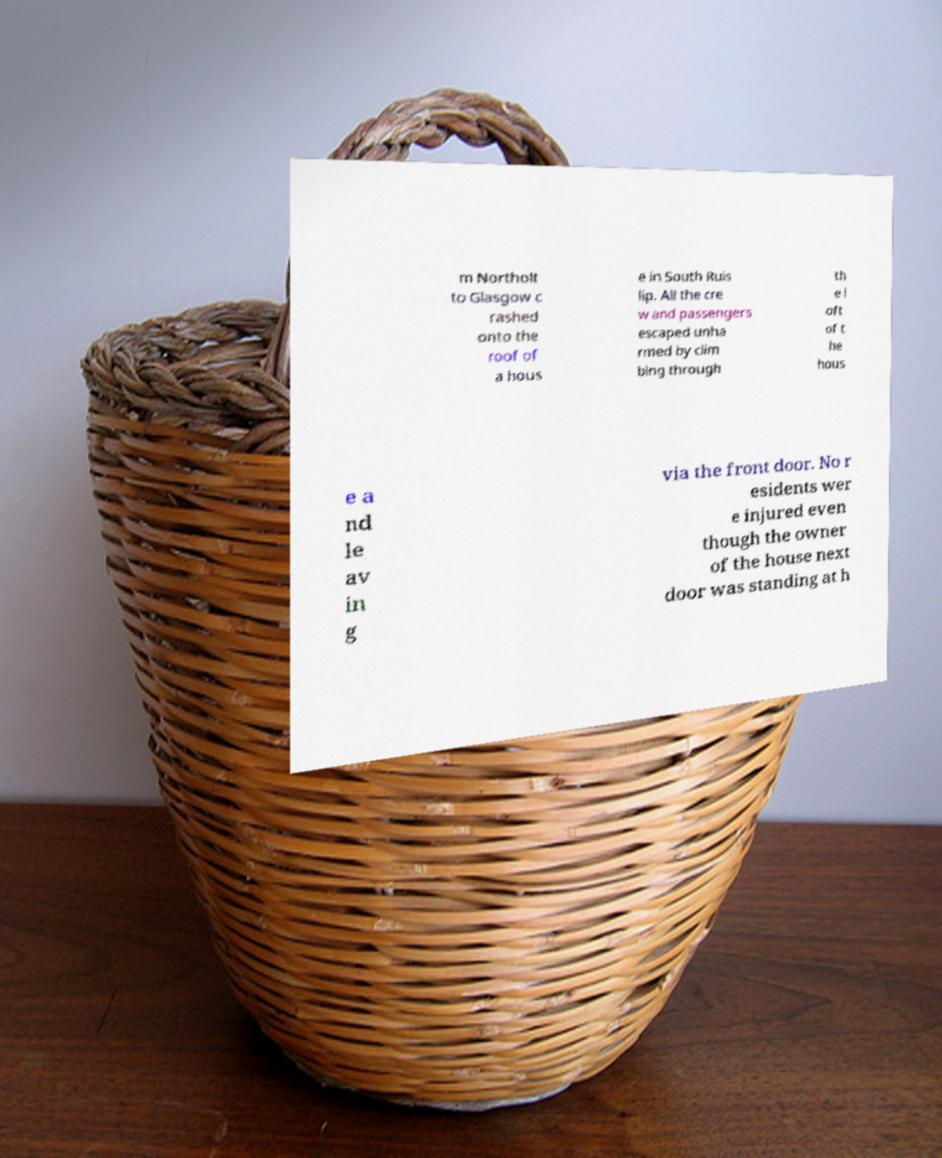Please identify and transcribe the text found in this image. m Northolt to Glasgow c rashed onto the roof of a hous e in South Ruis lip. All the cre w and passengers escaped unha rmed by clim bing through th e l oft of t he hous e a nd le av in g via the front door. No r esidents wer e injured even though the owner of the house next door was standing at h 